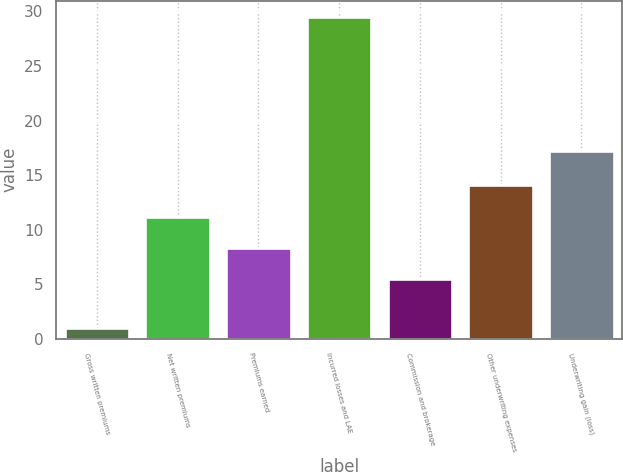<chart> <loc_0><loc_0><loc_500><loc_500><bar_chart><fcel>Gross written premiums<fcel>Net written premiums<fcel>Premiums earned<fcel>Incurred losses and LAE<fcel>Commission and brokerage<fcel>Other underwriting expenses<fcel>Underwriting gain (loss)<nl><fcel>1<fcel>11.2<fcel>8.35<fcel>29.5<fcel>5.5<fcel>14.05<fcel>17.2<nl></chart> 